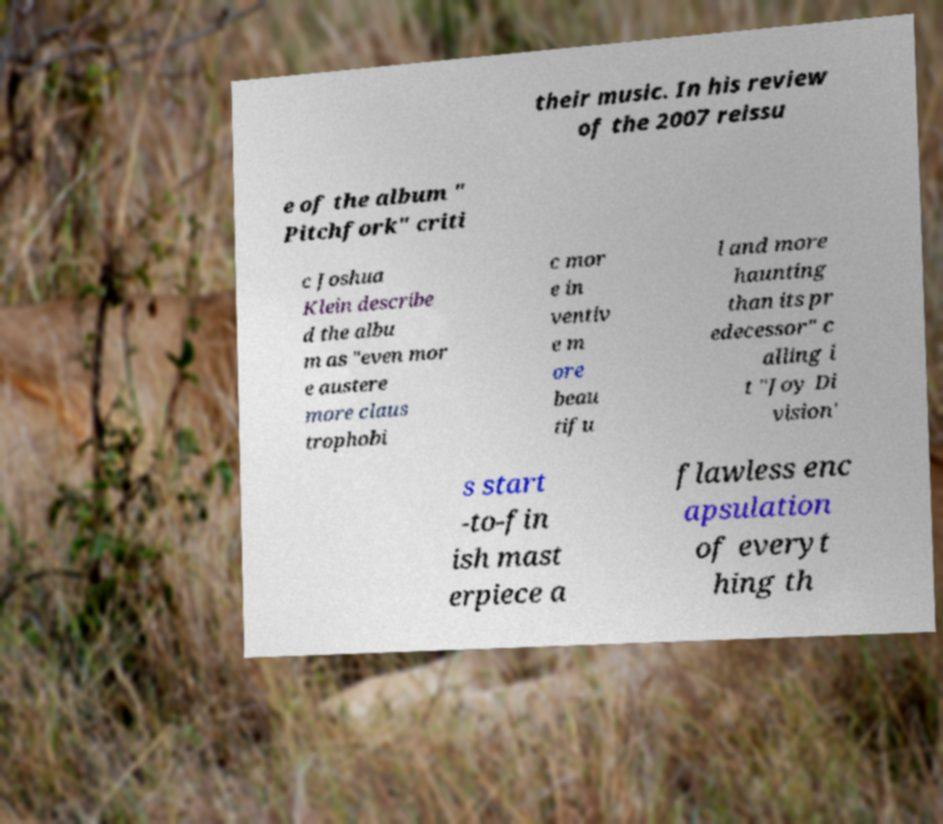For documentation purposes, I need the text within this image transcribed. Could you provide that? their music. In his review of the 2007 reissu e of the album " Pitchfork" criti c Joshua Klein describe d the albu m as "even mor e austere more claus trophobi c mor e in ventiv e m ore beau tifu l and more haunting than its pr edecessor" c alling i t "Joy Di vision' s start -to-fin ish mast erpiece a flawless enc apsulation of everyt hing th 